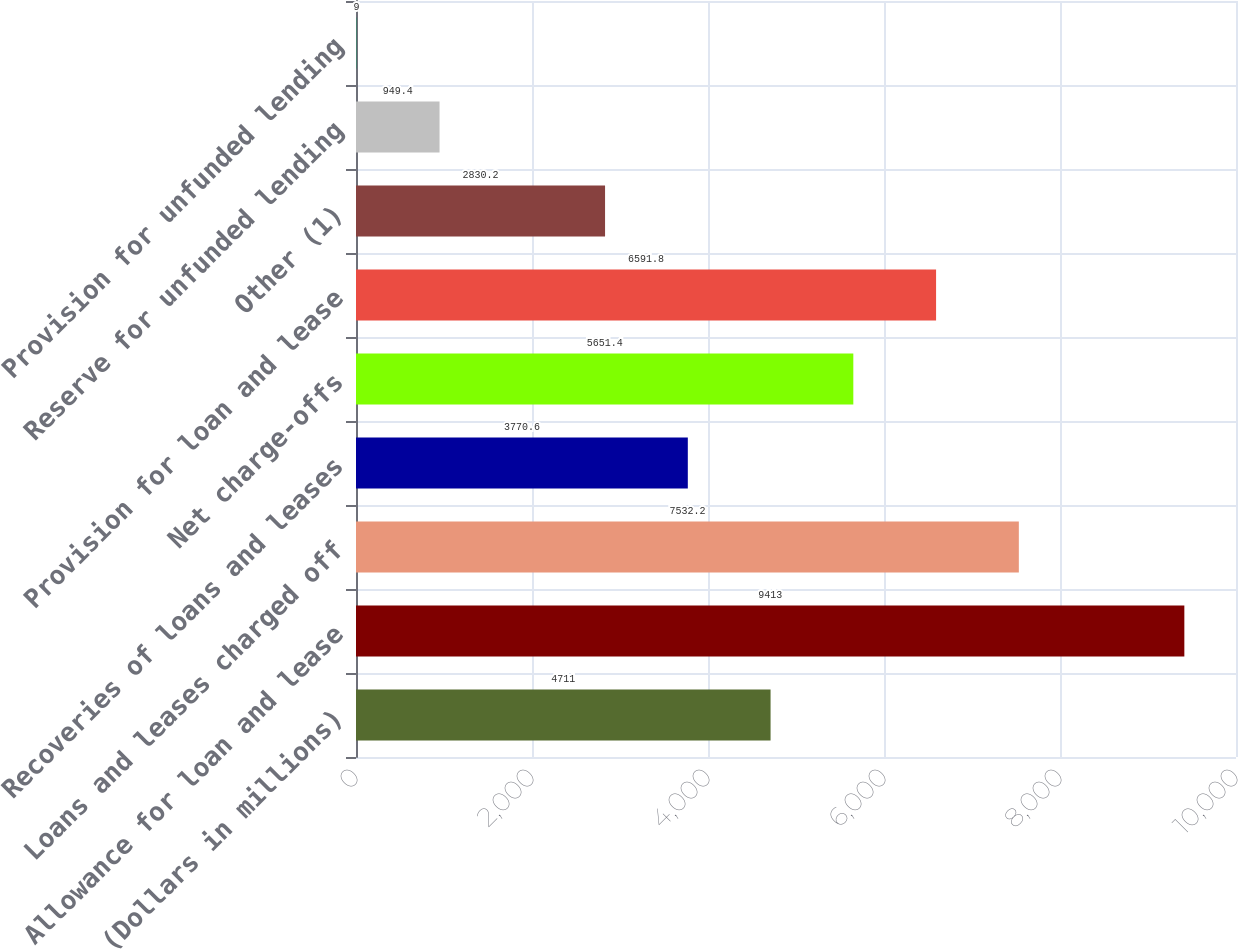<chart> <loc_0><loc_0><loc_500><loc_500><bar_chart><fcel>(Dollars in millions)<fcel>Allowance for loan and lease<fcel>Loans and leases charged off<fcel>Recoveries of loans and leases<fcel>Net charge-offs<fcel>Provision for loan and lease<fcel>Other (1)<fcel>Reserve for unfunded lending<fcel>Provision for unfunded lending<nl><fcel>4711<fcel>9413<fcel>7532.2<fcel>3770.6<fcel>5651.4<fcel>6591.8<fcel>2830.2<fcel>949.4<fcel>9<nl></chart> 